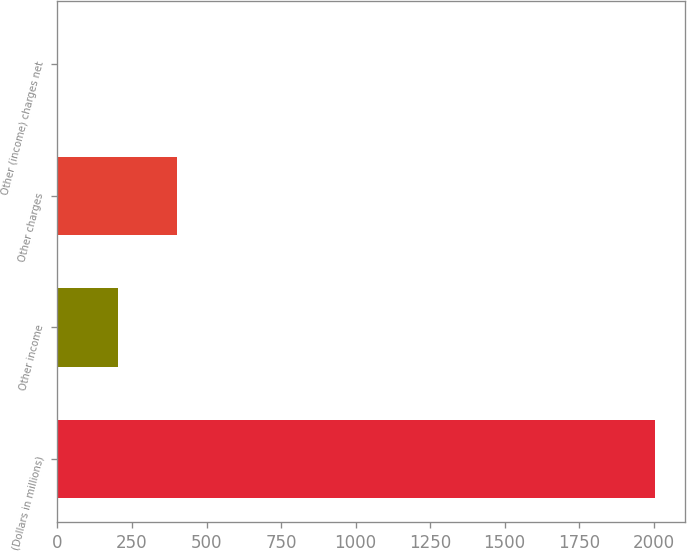Convert chart. <chart><loc_0><loc_0><loc_500><loc_500><bar_chart><fcel>(Dollars in millions)<fcel>Other income<fcel>Other charges<fcel>Other (income) charges net<nl><fcel>2005<fcel>201.4<fcel>401.8<fcel>1<nl></chart> 